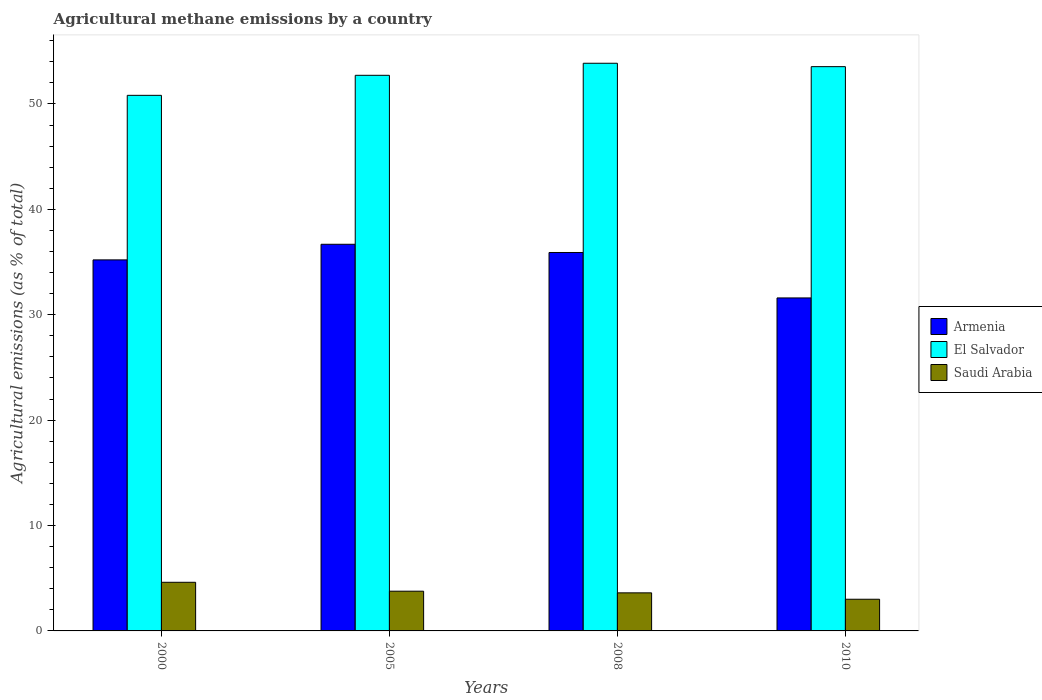How many different coloured bars are there?
Ensure brevity in your answer.  3. How many groups of bars are there?
Offer a terse response. 4. Are the number of bars per tick equal to the number of legend labels?
Make the answer very short. Yes. How many bars are there on the 2nd tick from the right?
Provide a short and direct response. 3. In how many cases, is the number of bars for a given year not equal to the number of legend labels?
Your answer should be compact. 0. What is the amount of agricultural methane emitted in El Salvador in 2010?
Your answer should be compact. 53.54. Across all years, what is the maximum amount of agricultural methane emitted in Armenia?
Give a very brief answer. 36.69. Across all years, what is the minimum amount of agricultural methane emitted in Armenia?
Offer a terse response. 31.59. What is the total amount of agricultural methane emitted in El Salvador in the graph?
Provide a succinct answer. 210.93. What is the difference between the amount of agricultural methane emitted in Armenia in 2008 and that in 2010?
Your answer should be very brief. 4.31. What is the difference between the amount of agricultural methane emitted in Saudi Arabia in 2008 and the amount of agricultural methane emitted in El Salvador in 2005?
Ensure brevity in your answer.  -49.11. What is the average amount of agricultural methane emitted in Armenia per year?
Ensure brevity in your answer.  34.85. In the year 2008, what is the difference between the amount of agricultural methane emitted in Armenia and amount of agricultural methane emitted in El Salvador?
Your response must be concise. -17.96. What is the ratio of the amount of agricultural methane emitted in El Salvador in 2005 to that in 2008?
Your answer should be very brief. 0.98. What is the difference between the highest and the second highest amount of agricultural methane emitted in El Salvador?
Give a very brief answer. 0.32. What is the difference between the highest and the lowest amount of agricultural methane emitted in El Salvador?
Offer a very short reply. 3.04. In how many years, is the amount of agricultural methane emitted in Armenia greater than the average amount of agricultural methane emitted in Armenia taken over all years?
Provide a short and direct response. 3. What does the 3rd bar from the left in 2005 represents?
Give a very brief answer. Saudi Arabia. What does the 1st bar from the right in 2005 represents?
Your answer should be very brief. Saudi Arabia. How many bars are there?
Your answer should be compact. 12. Are the values on the major ticks of Y-axis written in scientific E-notation?
Offer a terse response. No. Does the graph contain grids?
Provide a short and direct response. No. Where does the legend appear in the graph?
Give a very brief answer. Center right. How many legend labels are there?
Make the answer very short. 3. What is the title of the graph?
Give a very brief answer. Agricultural methane emissions by a country. What is the label or title of the X-axis?
Provide a succinct answer. Years. What is the label or title of the Y-axis?
Provide a succinct answer. Agricultural emissions (as % of total). What is the Agricultural emissions (as % of total) of Armenia in 2000?
Your answer should be very brief. 35.2. What is the Agricultural emissions (as % of total) in El Salvador in 2000?
Offer a terse response. 50.82. What is the Agricultural emissions (as % of total) of Saudi Arabia in 2000?
Offer a terse response. 4.61. What is the Agricultural emissions (as % of total) in Armenia in 2005?
Provide a succinct answer. 36.69. What is the Agricultural emissions (as % of total) of El Salvador in 2005?
Provide a short and direct response. 52.72. What is the Agricultural emissions (as % of total) of Saudi Arabia in 2005?
Your answer should be compact. 3.77. What is the Agricultural emissions (as % of total) of Armenia in 2008?
Your answer should be compact. 35.91. What is the Agricultural emissions (as % of total) in El Salvador in 2008?
Your answer should be very brief. 53.86. What is the Agricultural emissions (as % of total) in Saudi Arabia in 2008?
Your answer should be very brief. 3.61. What is the Agricultural emissions (as % of total) of Armenia in 2010?
Your answer should be very brief. 31.59. What is the Agricultural emissions (as % of total) of El Salvador in 2010?
Provide a succinct answer. 53.54. What is the Agricultural emissions (as % of total) in Saudi Arabia in 2010?
Your response must be concise. 3.01. Across all years, what is the maximum Agricultural emissions (as % of total) in Armenia?
Keep it short and to the point. 36.69. Across all years, what is the maximum Agricultural emissions (as % of total) of El Salvador?
Offer a terse response. 53.86. Across all years, what is the maximum Agricultural emissions (as % of total) in Saudi Arabia?
Give a very brief answer. 4.61. Across all years, what is the minimum Agricultural emissions (as % of total) in Armenia?
Your answer should be compact. 31.59. Across all years, what is the minimum Agricultural emissions (as % of total) of El Salvador?
Your response must be concise. 50.82. Across all years, what is the minimum Agricultural emissions (as % of total) of Saudi Arabia?
Ensure brevity in your answer.  3.01. What is the total Agricultural emissions (as % of total) of Armenia in the graph?
Provide a short and direct response. 139.39. What is the total Agricultural emissions (as % of total) in El Salvador in the graph?
Keep it short and to the point. 210.93. What is the total Agricultural emissions (as % of total) in Saudi Arabia in the graph?
Ensure brevity in your answer.  15. What is the difference between the Agricultural emissions (as % of total) of Armenia in 2000 and that in 2005?
Your response must be concise. -1.48. What is the difference between the Agricultural emissions (as % of total) of El Salvador in 2000 and that in 2005?
Your response must be concise. -1.9. What is the difference between the Agricultural emissions (as % of total) of Saudi Arabia in 2000 and that in 2005?
Make the answer very short. 0.84. What is the difference between the Agricultural emissions (as % of total) of Armenia in 2000 and that in 2008?
Your answer should be very brief. -0.7. What is the difference between the Agricultural emissions (as % of total) in El Salvador in 2000 and that in 2008?
Provide a succinct answer. -3.04. What is the difference between the Agricultural emissions (as % of total) in Saudi Arabia in 2000 and that in 2008?
Your answer should be very brief. 1. What is the difference between the Agricultural emissions (as % of total) of Armenia in 2000 and that in 2010?
Provide a succinct answer. 3.61. What is the difference between the Agricultural emissions (as % of total) in El Salvador in 2000 and that in 2010?
Ensure brevity in your answer.  -2.72. What is the difference between the Agricultural emissions (as % of total) of Saudi Arabia in 2000 and that in 2010?
Your answer should be compact. 1.61. What is the difference between the Agricultural emissions (as % of total) of Armenia in 2005 and that in 2008?
Your answer should be compact. 0.78. What is the difference between the Agricultural emissions (as % of total) in El Salvador in 2005 and that in 2008?
Your answer should be compact. -1.14. What is the difference between the Agricultural emissions (as % of total) of Saudi Arabia in 2005 and that in 2008?
Offer a terse response. 0.16. What is the difference between the Agricultural emissions (as % of total) of Armenia in 2005 and that in 2010?
Ensure brevity in your answer.  5.09. What is the difference between the Agricultural emissions (as % of total) in El Salvador in 2005 and that in 2010?
Ensure brevity in your answer.  -0.82. What is the difference between the Agricultural emissions (as % of total) in Saudi Arabia in 2005 and that in 2010?
Your answer should be compact. 0.76. What is the difference between the Agricultural emissions (as % of total) in Armenia in 2008 and that in 2010?
Your response must be concise. 4.31. What is the difference between the Agricultural emissions (as % of total) of El Salvador in 2008 and that in 2010?
Your answer should be very brief. 0.32. What is the difference between the Agricultural emissions (as % of total) in Saudi Arabia in 2008 and that in 2010?
Keep it short and to the point. 0.61. What is the difference between the Agricultural emissions (as % of total) of Armenia in 2000 and the Agricultural emissions (as % of total) of El Salvador in 2005?
Offer a very short reply. -17.51. What is the difference between the Agricultural emissions (as % of total) in Armenia in 2000 and the Agricultural emissions (as % of total) in Saudi Arabia in 2005?
Your answer should be compact. 31.44. What is the difference between the Agricultural emissions (as % of total) in El Salvador in 2000 and the Agricultural emissions (as % of total) in Saudi Arabia in 2005?
Offer a terse response. 47.05. What is the difference between the Agricultural emissions (as % of total) of Armenia in 2000 and the Agricultural emissions (as % of total) of El Salvador in 2008?
Offer a very short reply. -18.66. What is the difference between the Agricultural emissions (as % of total) of Armenia in 2000 and the Agricultural emissions (as % of total) of Saudi Arabia in 2008?
Your response must be concise. 31.59. What is the difference between the Agricultural emissions (as % of total) of El Salvador in 2000 and the Agricultural emissions (as % of total) of Saudi Arabia in 2008?
Give a very brief answer. 47.2. What is the difference between the Agricultural emissions (as % of total) in Armenia in 2000 and the Agricultural emissions (as % of total) in El Salvador in 2010?
Keep it short and to the point. -18.33. What is the difference between the Agricultural emissions (as % of total) of Armenia in 2000 and the Agricultural emissions (as % of total) of Saudi Arabia in 2010?
Offer a terse response. 32.2. What is the difference between the Agricultural emissions (as % of total) in El Salvador in 2000 and the Agricultural emissions (as % of total) in Saudi Arabia in 2010?
Offer a very short reply. 47.81. What is the difference between the Agricultural emissions (as % of total) of Armenia in 2005 and the Agricultural emissions (as % of total) of El Salvador in 2008?
Your answer should be compact. -17.18. What is the difference between the Agricultural emissions (as % of total) of Armenia in 2005 and the Agricultural emissions (as % of total) of Saudi Arabia in 2008?
Offer a very short reply. 33.07. What is the difference between the Agricultural emissions (as % of total) of El Salvador in 2005 and the Agricultural emissions (as % of total) of Saudi Arabia in 2008?
Offer a very short reply. 49.11. What is the difference between the Agricultural emissions (as % of total) of Armenia in 2005 and the Agricultural emissions (as % of total) of El Salvador in 2010?
Ensure brevity in your answer.  -16.85. What is the difference between the Agricultural emissions (as % of total) of Armenia in 2005 and the Agricultural emissions (as % of total) of Saudi Arabia in 2010?
Your answer should be compact. 33.68. What is the difference between the Agricultural emissions (as % of total) in El Salvador in 2005 and the Agricultural emissions (as % of total) in Saudi Arabia in 2010?
Provide a short and direct response. 49.71. What is the difference between the Agricultural emissions (as % of total) in Armenia in 2008 and the Agricultural emissions (as % of total) in El Salvador in 2010?
Make the answer very short. -17.63. What is the difference between the Agricultural emissions (as % of total) of Armenia in 2008 and the Agricultural emissions (as % of total) of Saudi Arabia in 2010?
Your answer should be very brief. 32.9. What is the difference between the Agricultural emissions (as % of total) in El Salvador in 2008 and the Agricultural emissions (as % of total) in Saudi Arabia in 2010?
Give a very brief answer. 50.86. What is the average Agricultural emissions (as % of total) of Armenia per year?
Make the answer very short. 34.85. What is the average Agricultural emissions (as % of total) of El Salvador per year?
Keep it short and to the point. 52.73. What is the average Agricultural emissions (as % of total) of Saudi Arabia per year?
Your response must be concise. 3.75. In the year 2000, what is the difference between the Agricultural emissions (as % of total) in Armenia and Agricultural emissions (as % of total) in El Salvador?
Your answer should be compact. -15.61. In the year 2000, what is the difference between the Agricultural emissions (as % of total) of Armenia and Agricultural emissions (as % of total) of Saudi Arabia?
Your response must be concise. 30.59. In the year 2000, what is the difference between the Agricultural emissions (as % of total) of El Salvador and Agricultural emissions (as % of total) of Saudi Arabia?
Your answer should be compact. 46.2. In the year 2005, what is the difference between the Agricultural emissions (as % of total) in Armenia and Agricultural emissions (as % of total) in El Salvador?
Give a very brief answer. -16.03. In the year 2005, what is the difference between the Agricultural emissions (as % of total) of Armenia and Agricultural emissions (as % of total) of Saudi Arabia?
Your answer should be compact. 32.92. In the year 2005, what is the difference between the Agricultural emissions (as % of total) of El Salvador and Agricultural emissions (as % of total) of Saudi Arabia?
Keep it short and to the point. 48.95. In the year 2008, what is the difference between the Agricultural emissions (as % of total) in Armenia and Agricultural emissions (as % of total) in El Salvador?
Give a very brief answer. -17.96. In the year 2008, what is the difference between the Agricultural emissions (as % of total) of Armenia and Agricultural emissions (as % of total) of Saudi Arabia?
Offer a terse response. 32.29. In the year 2008, what is the difference between the Agricultural emissions (as % of total) in El Salvador and Agricultural emissions (as % of total) in Saudi Arabia?
Ensure brevity in your answer.  50.25. In the year 2010, what is the difference between the Agricultural emissions (as % of total) in Armenia and Agricultural emissions (as % of total) in El Salvador?
Offer a terse response. -21.94. In the year 2010, what is the difference between the Agricultural emissions (as % of total) of Armenia and Agricultural emissions (as % of total) of Saudi Arabia?
Keep it short and to the point. 28.59. In the year 2010, what is the difference between the Agricultural emissions (as % of total) of El Salvador and Agricultural emissions (as % of total) of Saudi Arabia?
Offer a very short reply. 50.53. What is the ratio of the Agricultural emissions (as % of total) in Armenia in 2000 to that in 2005?
Offer a very short reply. 0.96. What is the ratio of the Agricultural emissions (as % of total) in El Salvador in 2000 to that in 2005?
Keep it short and to the point. 0.96. What is the ratio of the Agricultural emissions (as % of total) of Saudi Arabia in 2000 to that in 2005?
Make the answer very short. 1.22. What is the ratio of the Agricultural emissions (as % of total) in Armenia in 2000 to that in 2008?
Provide a short and direct response. 0.98. What is the ratio of the Agricultural emissions (as % of total) of El Salvador in 2000 to that in 2008?
Your answer should be very brief. 0.94. What is the ratio of the Agricultural emissions (as % of total) in Saudi Arabia in 2000 to that in 2008?
Your response must be concise. 1.28. What is the ratio of the Agricultural emissions (as % of total) in Armenia in 2000 to that in 2010?
Offer a very short reply. 1.11. What is the ratio of the Agricultural emissions (as % of total) of El Salvador in 2000 to that in 2010?
Your response must be concise. 0.95. What is the ratio of the Agricultural emissions (as % of total) in Saudi Arabia in 2000 to that in 2010?
Offer a very short reply. 1.54. What is the ratio of the Agricultural emissions (as % of total) in Armenia in 2005 to that in 2008?
Provide a short and direct response. 1.02. What is the ratio of the Agricultural emissions (as % of total) in El Salvador in 2005 to that in 2008?
Give a very brief answer. 0.98. What is the ratio of the Agricultural emissions (as % of total) in Saudi Arabia in 2005 to that in 2008?
Offer a terse response. 1.04. What is the ratio of the Agricultural emissions (as % of total) in Armenia in 2005 to that in 2010?
Provide a succinct answer. 1.16. What is the ratio of the Agricultural emissions (as % of total) in El Salvador in 2005 to that in 2010?
Your answer should be compact. 0.98. What is the ratio of the Agricultural emissions (as % of total) in Saudi Arabia in 2005 to that in 2010?
Ensure brevity in your answer.  1.25. What is the ratio of the Agricultural emissions (as % of total) in Armenia in 2008 to that in 2010?
Make the answer very short. 1.14. What is the ratio of the Agricultural emissions (as % of total) of Saudi Arabia in 2008 to that in 2010?
Give a very brief answer. 1.2. What is the difference between the highest and the second highest Agricultural emissions (as % of total) of Armenia?
Your response must be concise. 0.78. What is the difference between the highest and the second highest Agricultural emissions (as % of total) in El Salvador?
Your answer should be very brief. 0.32. What is the difference between the highest and the second highest Agricultural emissions (as % of total) in Saudi Arabia?
Make the answer very short. 0.84. What is the difference between the highest and the lowest Agricultural emissions (as % of total) of Armenia?
Make the answer very short. 5.09. What is the difference between the highest and the lowest Agricultural emissions (as % of total) of El Salvador?
Your answer should be very brief. 3.04. What is the difference between the highest and the lowest Agricultural emissions (as % of total) in Saudi Arabia?
Your answer should be very brief. 1.61. 